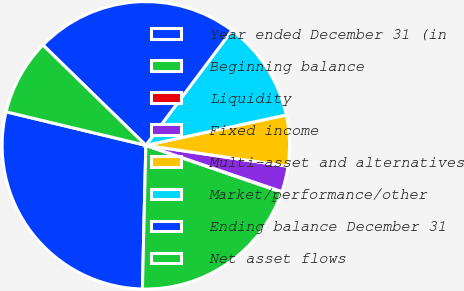Convert chart to OTSL. <chart><loc_0><loc_0><loc_500><loc_500><pie_chart><fcel>Year ended December 31 (in<fcel>Beginning balance<fcel>Liquidity<fcel>Fixed income<fcel>Multi-asset and alternatives<fcel>Market/performance/other<fcel>Ending balance December 31<fcel>Net asset flows<nl><fcel>28.37%<fcel>20.1%<fcel>0.06%<fcel>2.89%<fcel>5.72%<fcel>11.38%<fcel>22.93%<fcel>8.55%<nl></chart> 